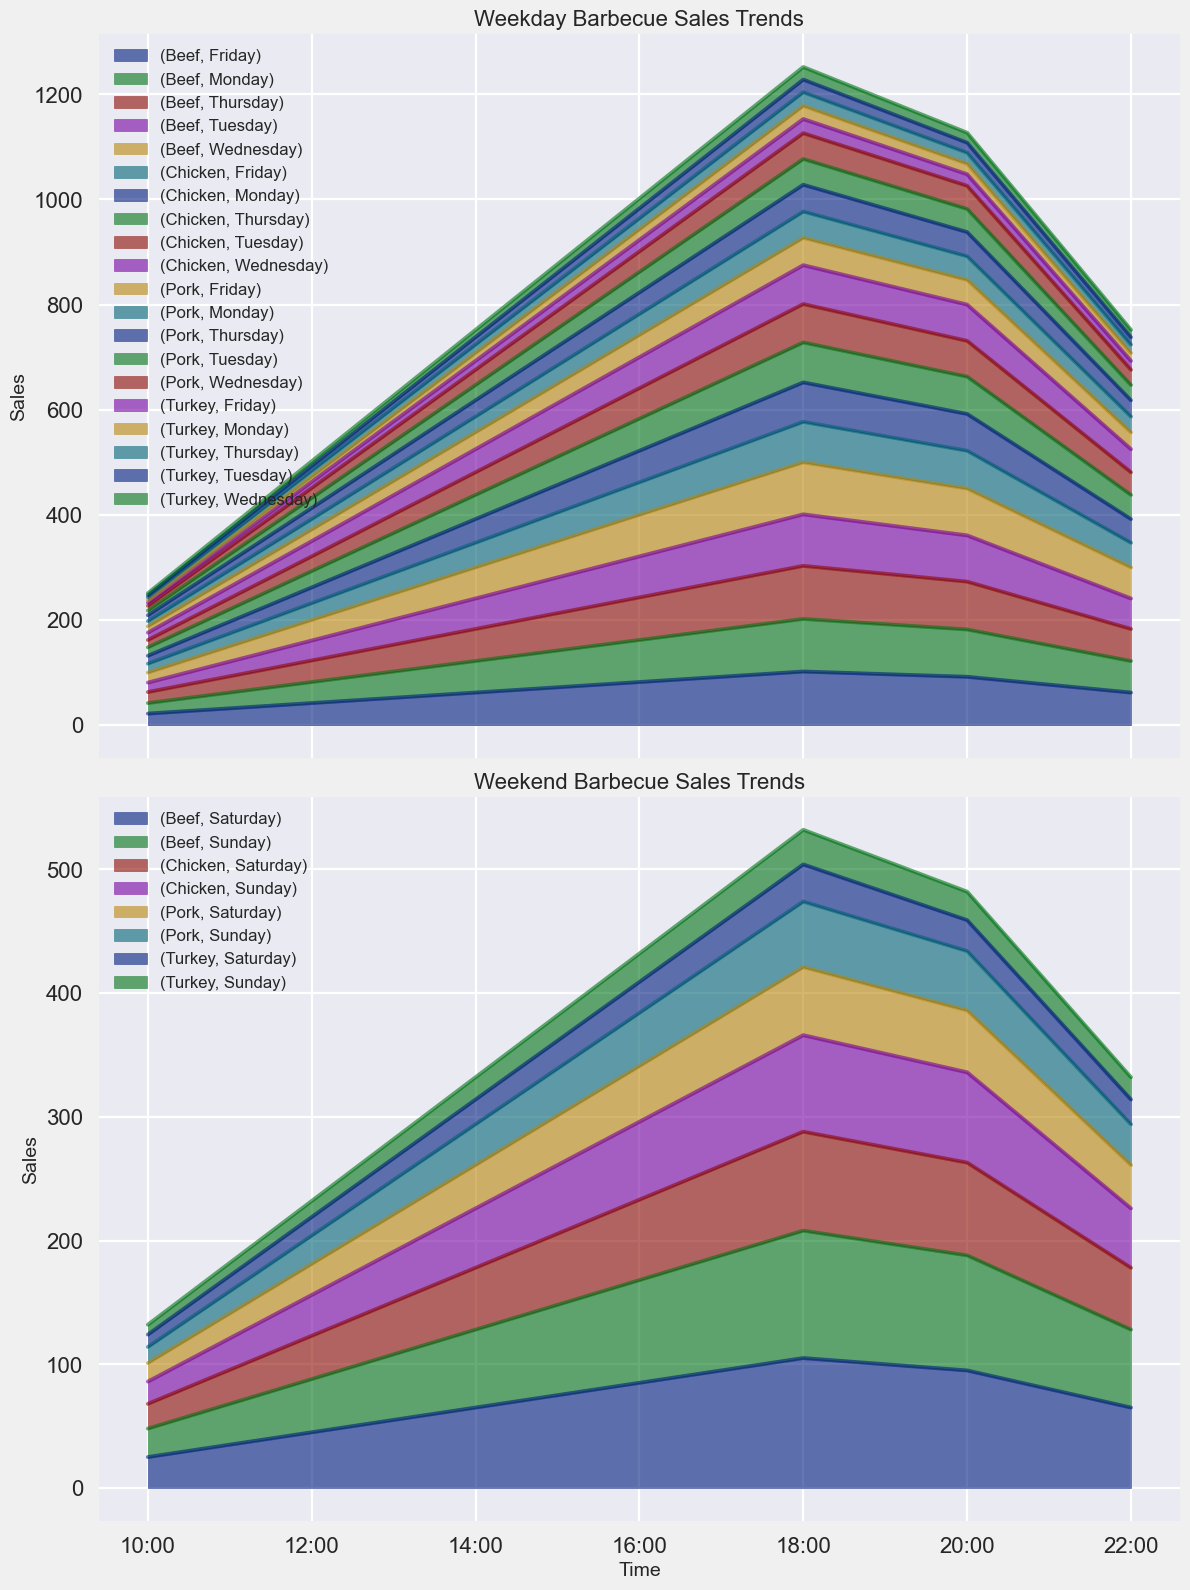Which day has the highest sales for beef? By inspecting the peak areas for each weekday and comparing their heights, it's evident that Thursday has the highest sales for beef around 18:00.
Answer: Thursday How do chicken sales on Monday at 18:00 compare to those on Saturday at the same time? Look at the height of the chicken area for Monday at 18:00 and compare it to the height at the same time on Saturday. Monday's sales are slightly lower than Saturday's.
Answer: Lower on Monday On average, do weekend beef sales outperform weekday beef sales during peak hours? Calculate the average sales of beef during peak hours (18:00) for both weekends (Saturday and Sunday) and weekdays (Monday to Friday). Weekends tend to show higher average sales.
Answer: Yes Between pork and turkey, which is more popular during weekend evenings? Compare the areas of pork and turkey from 18:00 to 22:00 on the weekend charts. Pork consistently shows higher sales than turkey.
Answer: Pork What time shows the highest combined sales of all meats on weekdays? Determine the combined height of all meat areas (beef, chicken, pork, turkey) on the weekday chart and identify the time with the peak height, which is 18:00.
Answer: 18:00 Are there any noticeable patterns in the sales trends of turkey across weekdays and weekends? Observing the turkey area across all days, it shows a consistent but low pattern with slight increases during peak hours (18:00) with higher sales on weekends.
Answer: Consistent with peaks at 18:00 Which meat shows the least variability in sales throughout the week? Assess the uniformity of the areas for each type of meat across all days. Turkey has the least variability, with consistent but low sales.
Answer: Turkey Do Saturday or Sunday sales exhibit a wider range of times with high sales compared to weekdays? Examine the width and height of the areas indicating high sales (18:00 - 22:00) on weekends compared to similar patterns on weekdays. Weekends exhibit consistently higher sales over a broader timeframe.
Answer: Yes 